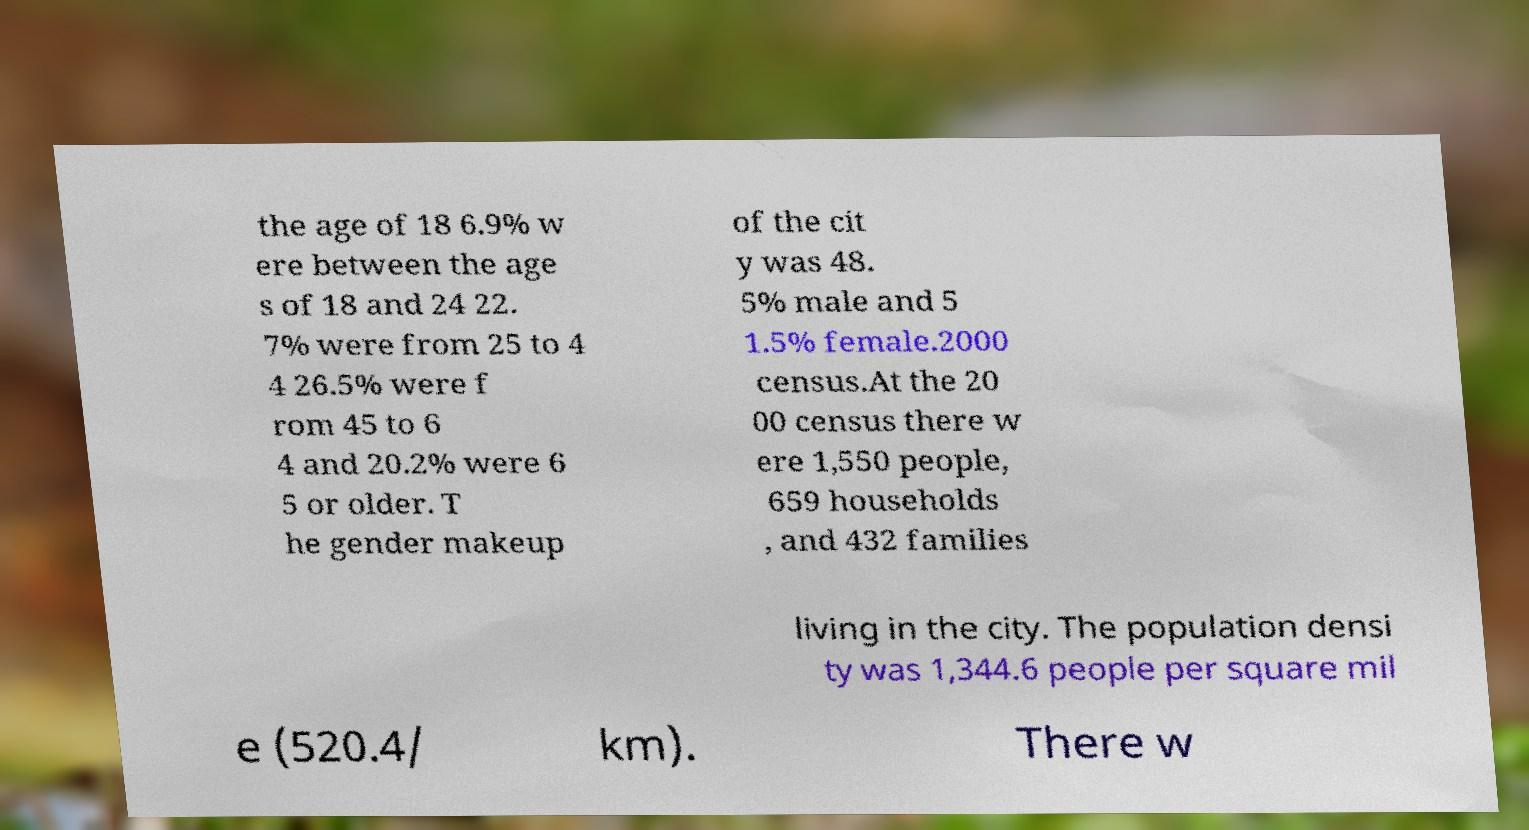Can you read and provide the text displayed in the image?This photo seems to have some interesting text. Can you extract and type it out for me? the age of 18 6.9% w ere between the age s of 18 and 24 22. 7% were from 25 to 4 4 26.5% were f rom 45 to 6 4 and 20.2% were 6 5 or older. T he gender makeup of the cit y was 48. 5% male and 5 1.5% female.2000 census.At the 20 00 census there w ere 1,550 people, 659 households , and 432 families living in the city. The population densi ty was 1,344.6 people per square mil e (520.4/ km). There w 